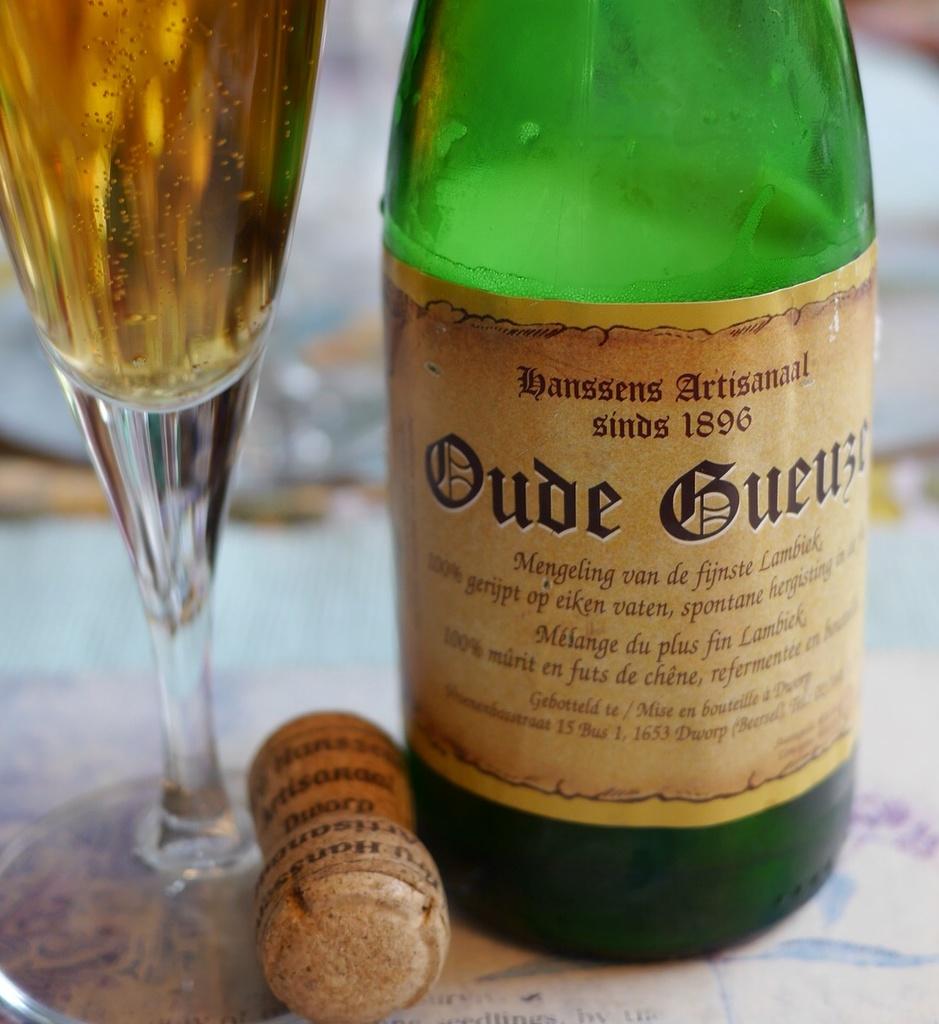When was this brand established?
Offer a very short reply. 1896. 